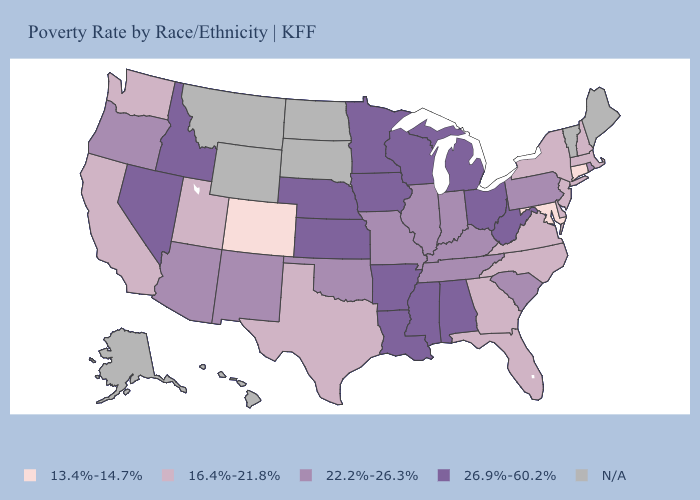Does Minnesota have the highest value in the USA?
Be succinct. Yes. Does Oregon have the lowest value in the USA?
Quick response, please. No. Among the states that border Kansas , which have the highest value?
Answer briefly. Nebraska. Does the map have missing data?
Give a very brief answer. Yes. Does New Hampshire have the highest value in the Northeast?
Quick response, please. No. What is the highest value in states that border Oklahoma?
Give a very brief answer. 26.9%-60.2%. What is the highest value in the Northeast ?
Concise answer only. 22.2%-26.3%. Among the states that border New York , which have the highest value?
Concise answer only. Pennsylvania. What is the value of Wyoming?
Concise answer only. N/A. Name the states that have a value in the range 26.9%-60.2%?
Quick response, please. Alabama, Arkansas, Idaho, Iowa, Kansas, Louisiana, Michigan, Minnesota, Mississippi, Nebraska, Nevada, Ohio, West Virginia, Wisconsin. Name the states that have a value in the range 26.9%-60.2%?
Concise answer only. Alabama, Arkansas, Idaho, Iowa, Kansas, Louisiana, Michigan, Minnesota, Mississippi, Nebraska, Nevada, Ohio, West Virginia, Wisconsin. What is the value of Delaware?
Concise answer only. 16.4%-21.8%. Name the states that have a value in the range 26.9%-60.2%?
Write a very short answer. Alabama, Arkansas, Idaho, Iowa, Kansas, Louisiana, Michigan, Minnesota, Mississippi, Nebraska, Nevada, Ohio, West Virginia, Wisconsin. Name the states that have a value in the range N/A?
Short answer required. Alaska, Hawaii, Maine, Montana, North Dakota, South Dakota, Vermont, Wyoming. 